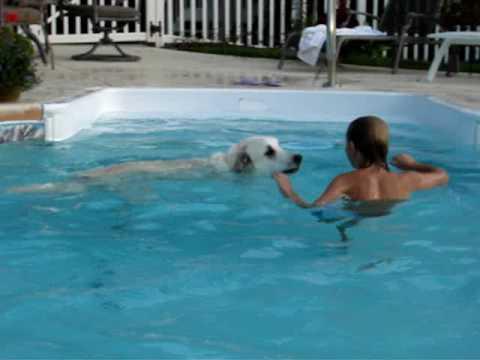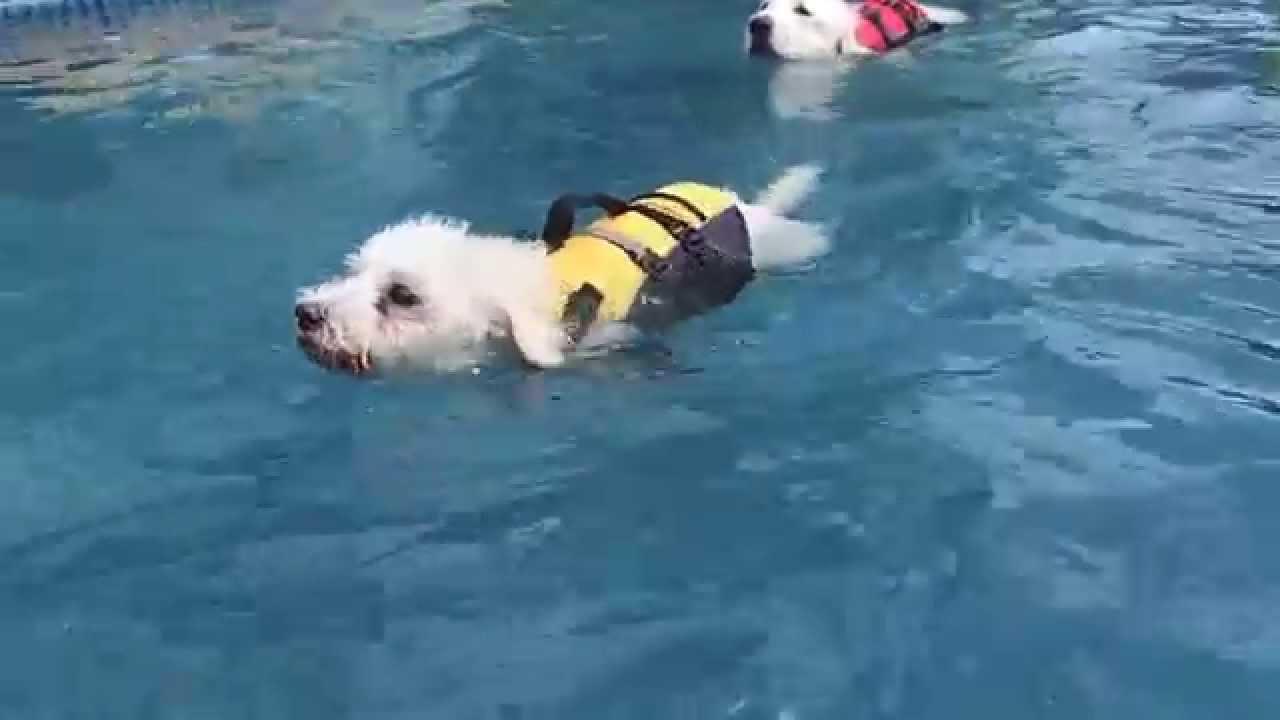The first image is the image on the left, the second image is the image on the right. Examine the images to the left and right. Is the description "There is a person in the water in one of the images." accurate? Answer yes or no. Yes. The first image is the image on the left, the second image is the image on the right. Given the left and right images, does the statement "At least one image shows a dog actually swimming in a pool." hold true? Answer yes or no. Yes. 